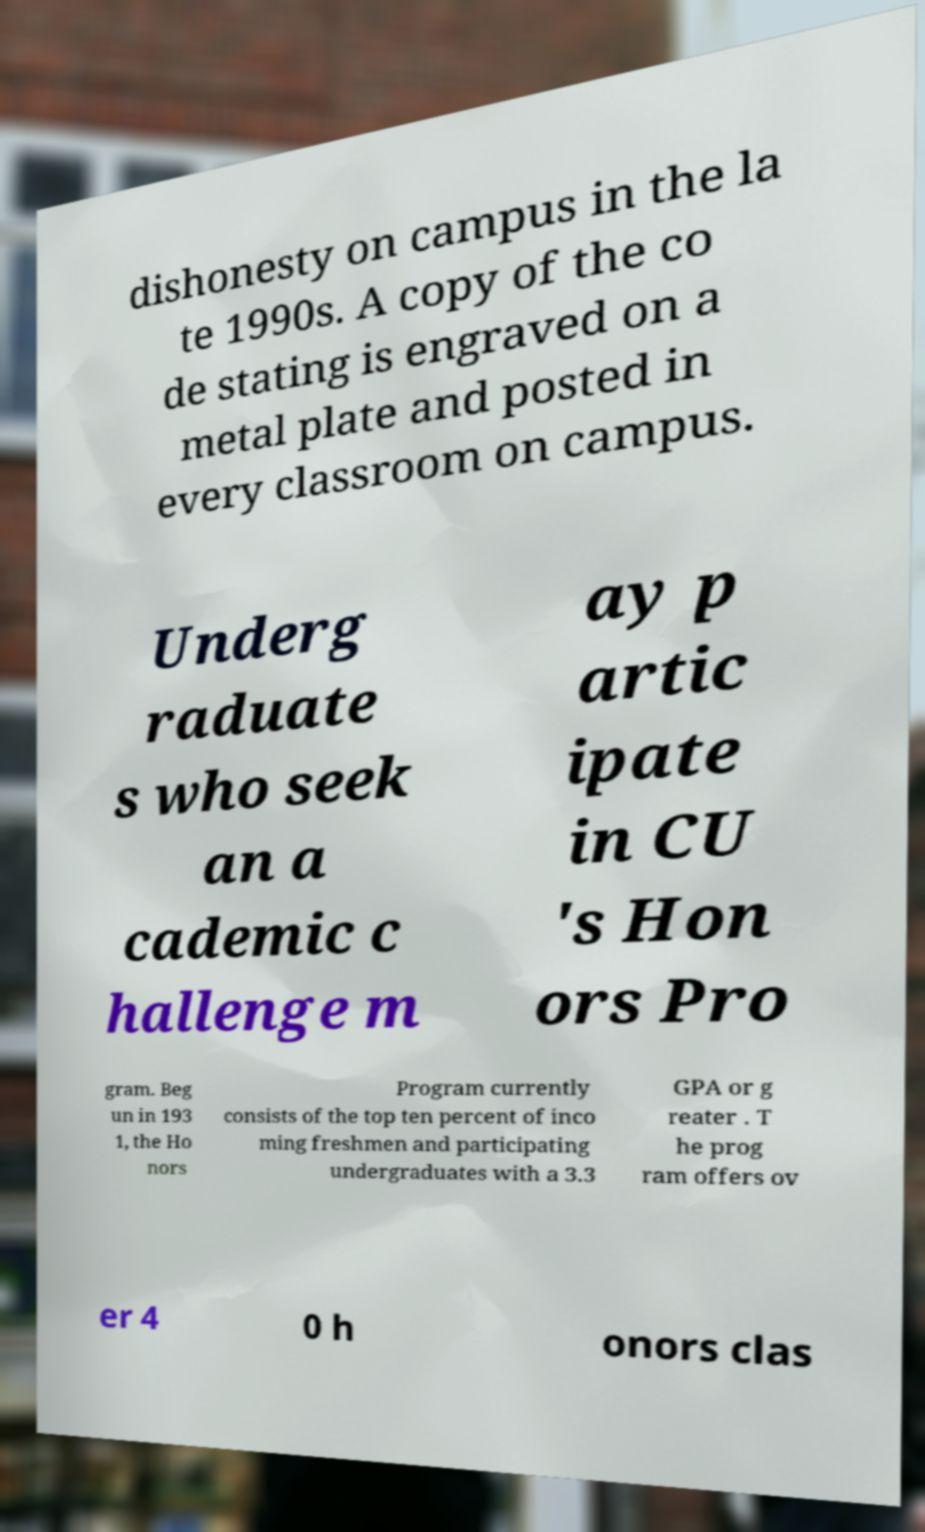What messages or text are displayed in this image? I need them in a readable, typed format. dishonesty on campus in the la te 1990s. A copy of the co de stating is engraved on a metal plate and posted in every classroom on campus. Underg raduate s who seek an a cademic c hallenge m ay p artic ipate in CU 's Hon ors Pro gram. Beg un in 193 1, the Ho nors Program currently consists of the top ten percent of inco ming freshmen and participating undergraduates with a 3.3 GPA or g reater . T he prog ram offers ov er 4 0 h onors clas 